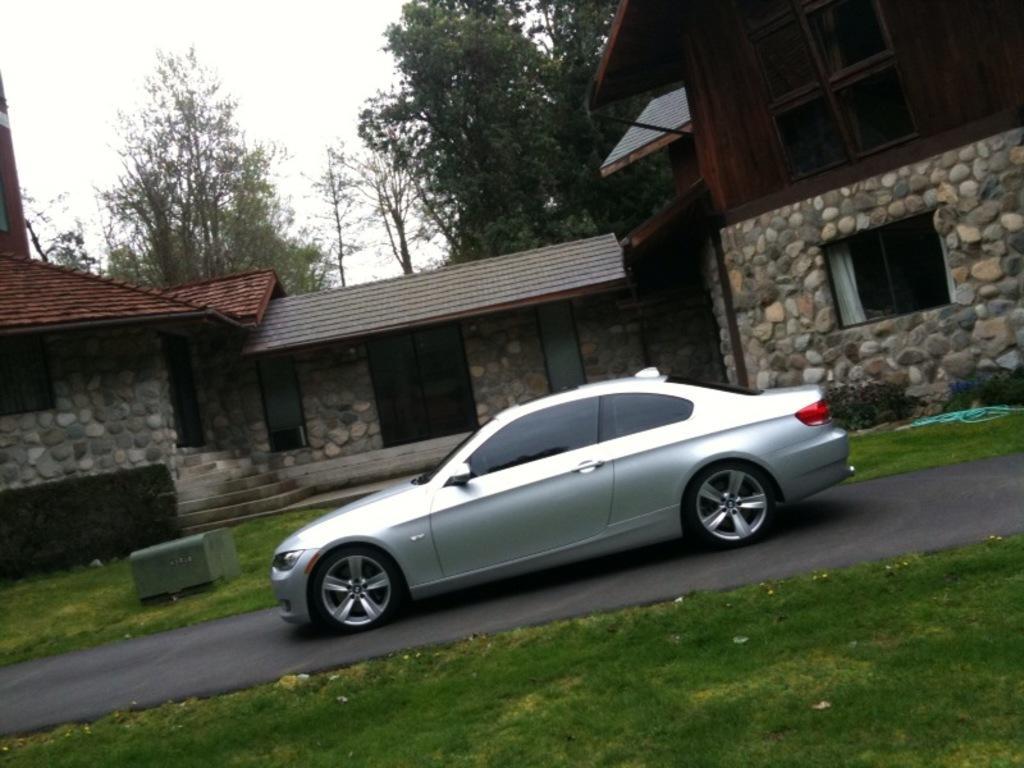Can you describe this image briefly? In the picture I can see car on the road, beside we can see some houses, trees and grass. 